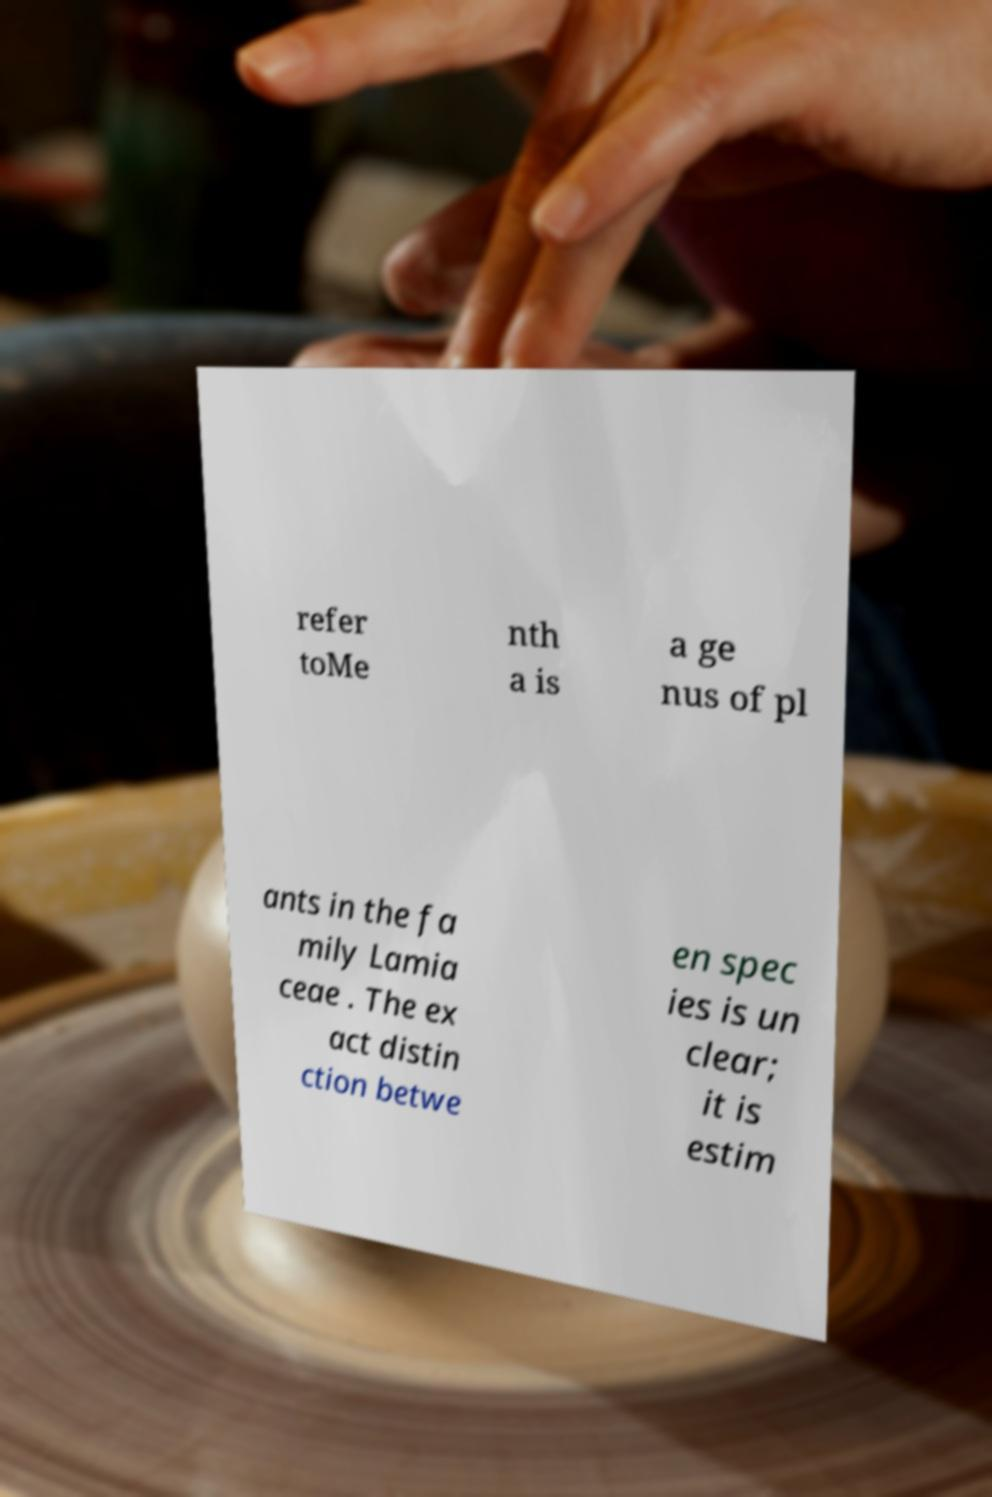Please read and relay the text visible in this image. What does it say? refer toMe nth a is a ge nus of pl ants in the fa mily Lamia ceae . The ex act distin ction betwe en spec ies is un clear; it is estim 